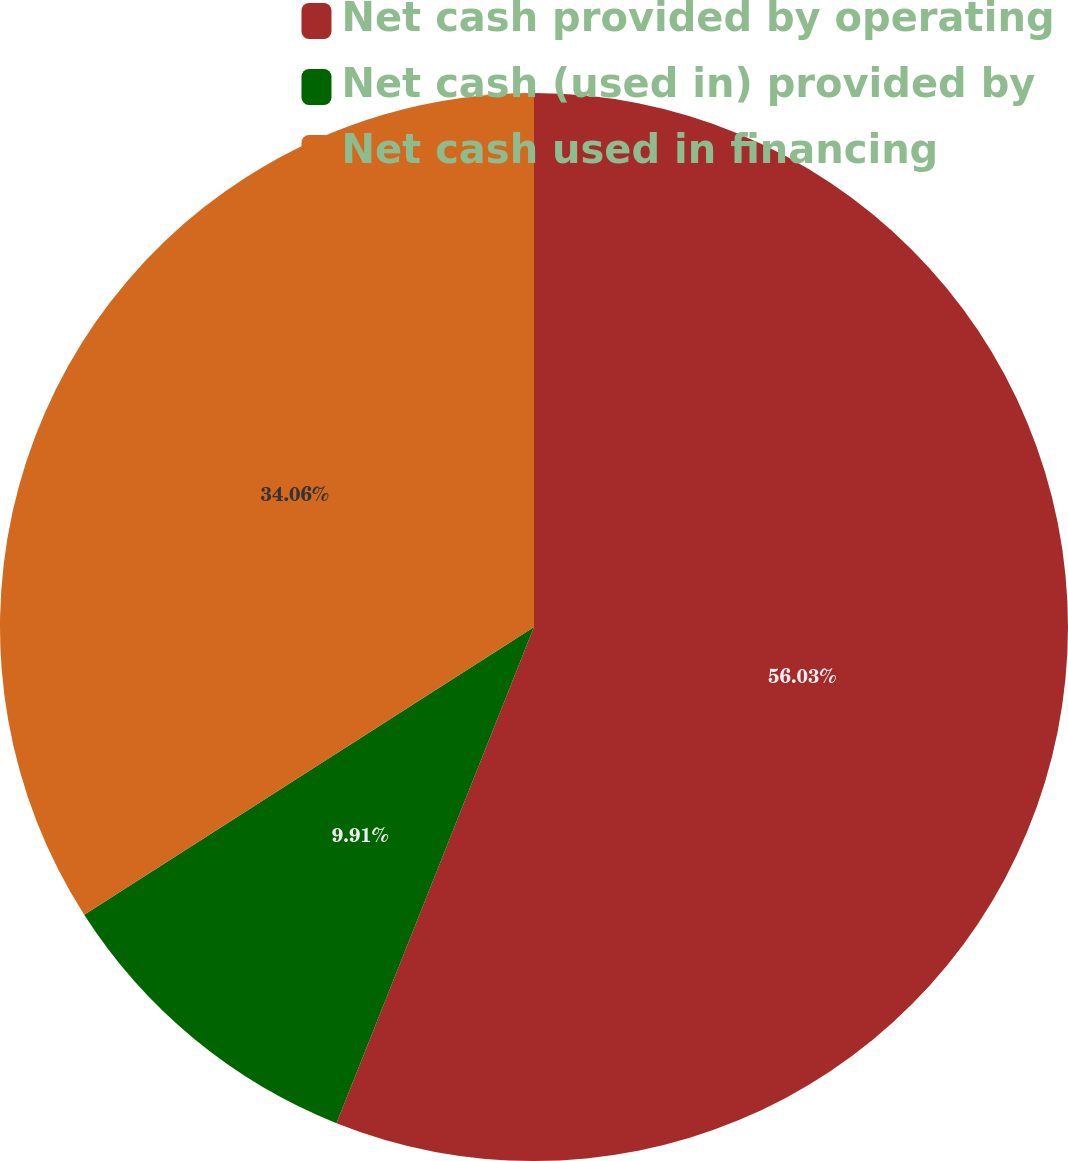Convert chart to OTSL. <chart><loc_0><loc_0><loc_500><loc_500><pie_chart><fcel>Net cash provided by operating<fcel>Net cash (used in) provided by<fcel>Net cash used in financing<nl><fcel>56.03%<fcel>9.91%<fcel>34.06%<nl></chart> 